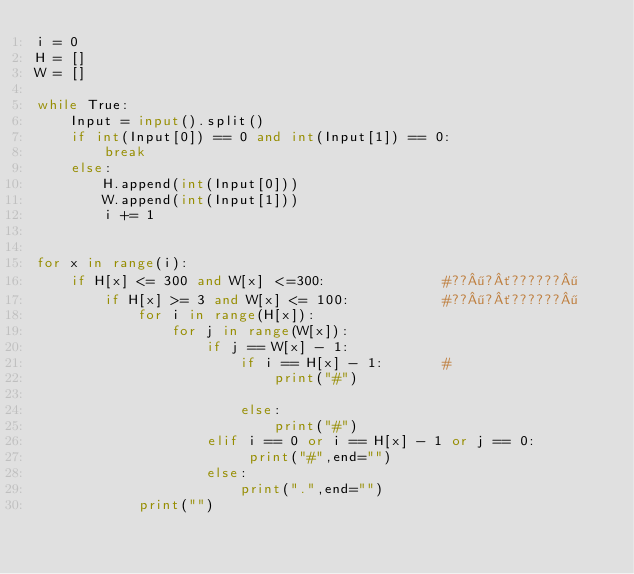<code> <loc_0><loc_0><loc_500><loc_500><_Python_>i = 0
H = []
W = []

while True:
    Input = input().split()
    if int(Input[0]) == 0 and int(Input[1]) == 0:
        break
    else:
        H.append(int(Input[0]))
        W.append(int(Input[1]))
        i += 1


for x in range(i):
    if H[x] <= 300 and W[x] <=300:              #??¶?´??????¶
        if H[x] >= 3 and W[x] <= 100:           #??¶?´??????¶
            for i in range(H[x]):
                for j in range(W[x]):
                    if j == W[x] - 1:
                        if i == H[x] - 1:       #
                            print("#")

                        else:
                            print("#")
                    elif i == 0 or i == H[x] - 1 or j == 0:
                         print("#",end="")
                    else:
                        print(".",end="")
            print("")</code> 